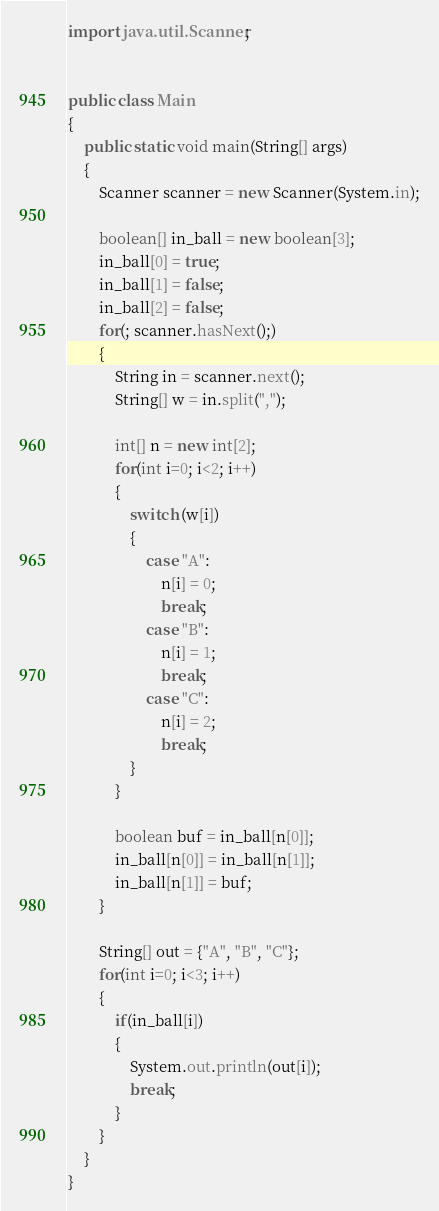Convert code to text. <code><loc_0><loc_0><loc_500><loc_500><_Java_>import java.util.Scanner;


public class Main
{
	public static void main(String[] args)
	{
		Scanner scanner = new Scanner(System.in);
		
		boolean[] in_ball = new boolean[3];
		in_ball[0] = true;
		in_ball[1] = false;
		in_ball[2] = false;
		for(; scanner.hasNext();)
		{
			String in = scanner.next();
			String[] w = in.split(",");
			
			int[] n = new int[2];
			for(int i=0; i<2; i++)
			{
				switch (w[i])
				{
					case "A":
						n[i] = 0;
						break;
					case "B":
						n[i] = 1;
						break;
					case "C":
						n[i] = 2;
						break;
				}
			}
			
			boolean buf = in_ball[n[0]];
			in_ball[n[0]] = in_ball[n[1]];
			in_ball[n[1]] = buf;
		}
		
		String[] out = {"A", "B", "C"};
		for(int i=0; i<3; i++)
		{
			if(in_ball[i])
			{
				System.out.println(out[i]);
				break;
			}
		}
	}
}</code> 